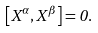Convert formula to latex. <formula><loc_0><loc_0><loc_500><loc_500>\left [ X ^ { \alpha } , X ^ { \beta } \right ] = 0 .</formula> 